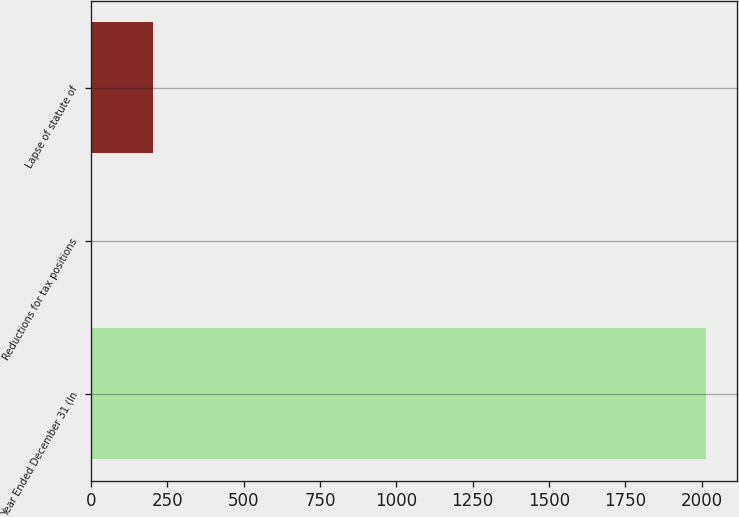Convert chart to OTSL. <chart><loc_0><loc_0><loc_500><loc_500><bar_chart><fcel>Year Ended December 31 (In<fcel>Reductions for tax positions<fcel>Lapse of statute of<nl><fcel>2015<fcel>3<fcel>204.2<nl></chart> 